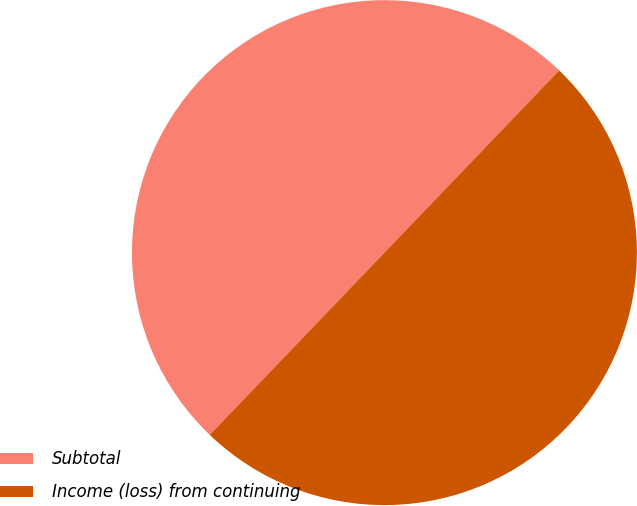Convert chart to OTSL. <chart><loc_0><loc_0><loc_500><loc_500><pie_chart><fcel>Subtotal<fcel>Income (loss) from continuing<nl><fcel>50.0%<fcel>50.0%<nl></chart> 